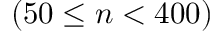Convert formula to latex. <formula><loc_0><loc_0><loc_500><loc_500>( 5 0 \leq n < 4 0 0 )</formula> 